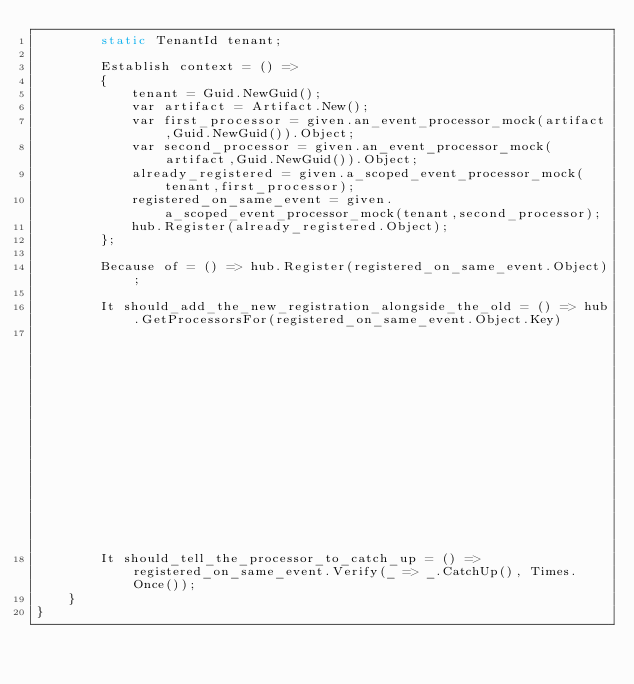Convert code to text. <code><loc_0><loc_0><loc_500><loc_500><_C#_>        static TenantId tenant;

        Establish context = () => 
        {
            tenant = Guid.NewGuid();
            var artifact = Artifact.New();
            var first_processor = given.an_event_processor_mock(artifact,Guid.NewGuid()).Object;
            var second_processor = given.an_event_processor_mock(artifact,Guid.NewGuid()).Object;
            already_registered = given.a_scoped_event_processor_mock(tenant,first_processor);
            registered_on_same_event = given.a_scoped_event_processor_mock(tenant,second_processor);
            hub.Register(already_registered.Object);
        };

        Because of = () => hub.Register(registered_on_same_event.Object);

        It should_add_the_new_registration_alongside_the_old = () => hub.GetProcessorsFor(registered_on_same_event.Object.Key)
                                                                            .ShouldContainOnly(new []{already_registered.Object, registered_on_same_event.Object});
        It should_tell_the_processor_to_catch_up = () => registered_on_same_event.Verify(_ => _.CatchUp(), Times.Once());
    }
}</code> 